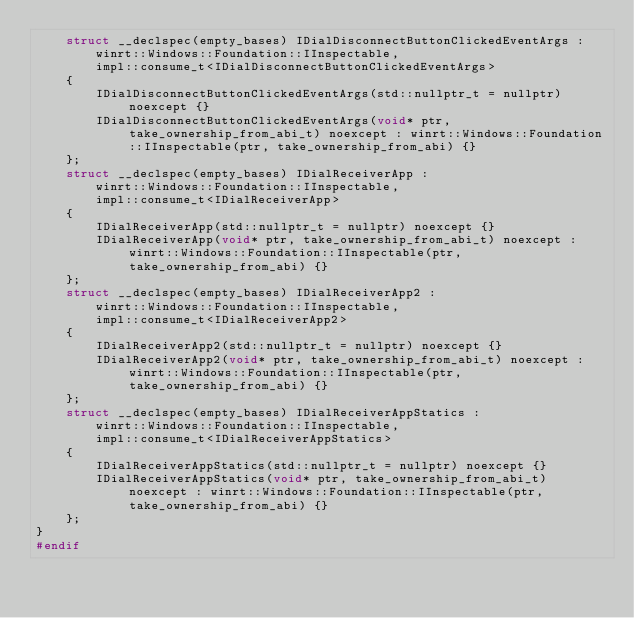<code> <loc_0><loc_0><loc_500><loc_500><_C_>    struct __declspec(empty_bases) IDialDisconnectButtonClickedEventArgs :
        winrt::Windows::Foundation::IInspectable,
        impl::consume_t<IDialDisconnectButtonClickedEventArgs>
    {
        IDialDisconnectButtonClickedEventArgs(std::nullptr_t = nullptr) noexcept {}
        IDialDisconnectButtonClickedEventArgs(void* ptr, take_ownership_from_abi_t) noexcept : winrt::Windows::Foundation::IInspectable(ptr, take_ownership_from_abi) {}
    };
    struct __declspec(empty_bases) IDialReceiverApp :
        winrt::Windows::Foundation::IInspectable,
        impl::consume_t<IDialReceiverApp>
    {
        IDialReceiverApp(std::nullptr_t = nullptr) noexcept {}
        IDialReceiverApp(void* ptr, take_ownership_from_abi_t) noexcept : winrt::Windows::Foundation::IInspectable(ptr, take_ownership_from_abi) {}
    };
    struct __declspec(empty_bases) IDialReceiverApp2 :
        winrt::Windows::Foundation::IInspectable,
        impl::consume_t<IDialReceiverApp2>
    {
        IDialReceiverApp2(std::nullptr_t = nullptr) noexcept {}
        IDialReceiverApp2(void* ptr, take_ownership_from_abi_t) noexcept : winrt::Windows::Foundation::IInspectable(ptr, take_ownership_from_abi) {}
    };
    struct __declspec(empty_bases) IDialReceiverAppStatics :
        winrt::Windows::Foundation::IInspectable,
        impl::consume_t<IDialReceiverAppStatics>
    {
        IDialReceiverAppStatics(std::nullptr_t = nullptr) noexcept {}
        IDialReceiverAppStatics(void* ptr, take_ownership_from_abi_t) noexcept : winrt::Windows::Foundation::IInspectable(ptr, take_ownership_from_abi) {}
    };
}
#endif
</code> 